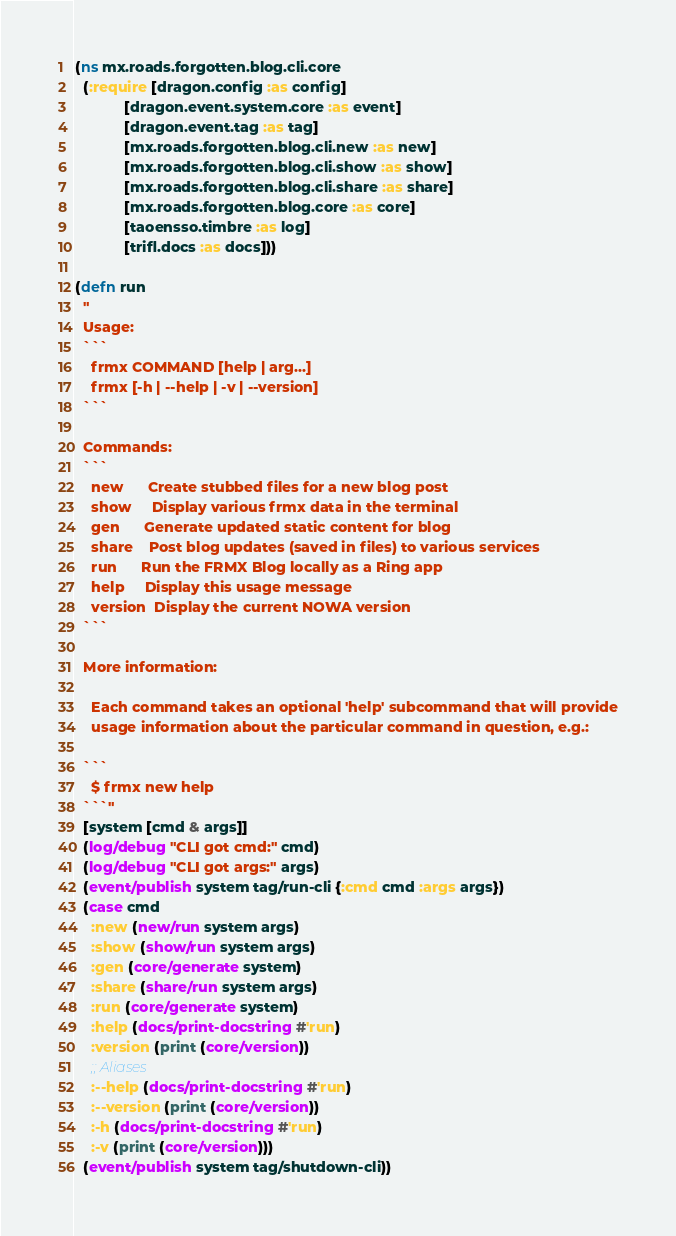Convert code to text. <code><loc_0><loc_0><loc_500><loc_500><_Clojure_>(ns mx.roads.forgotten.blog.cli.core
  (:require [dragon.config :as config]
            [dragon.event.system.core :as event]
            [dragon.event.tag :as tag]
            [mx.roads.forgotten.blog.cli.new :as new]
            [mx.roads.forgotten.blog.cli.show :as show]
            [mx.roads.forgotten.blog.cli.share :as share]
            [mx.roads.forgotten.blog.core :as core]
            [taoensso.timbre :as log]
            [trifl.docs :as docs]))

(defn run
  "
  Usage:
  ```
    frmx COMMAND [help | arg...]
    frmx [-h | --help | -v | --version]
  ```

  Commands:
  ```
    new      Create stubbed files for a new blog post
    show     Display various frmx data in the terminal
    gen      Generate updated static content for blog
    share    Post blog updates (saved in files) to various services
    run      Run the FRMX Blog locally as a Ring app
    help     Display this usage message
    version  Display the current NOWA version
  ```

  More information:

    Each command takes an optional 'help' subcommand that will provide
    usage information about the particular command in question, e.g.:

  ```
    $ frmx new help
  ```"
  [system [cmd & args]]
  (log/debug "CLI got cmd:" cmd)
  (log/debug "CLI got args:" args)
  (event/publish system tag/run-cli {:cmd cmd :args args})
  (case cmd
    :new (new/run system args)
    :show (show/run system args)
    :gen (core/generate system)
    :share (share/run system args)
    :run (core/generate system)
    :help (docs/print-docstring #'run)
    :version (print (core/version))
    ;; Aliases
    :--help (docs/print-docstring #'run)
    :--version (print (core/version))
    :-h (docs/print-docstring #'run)
    :-v (print (core/version)))
  (event/publish system tag/shutdown-cli))
</code> 